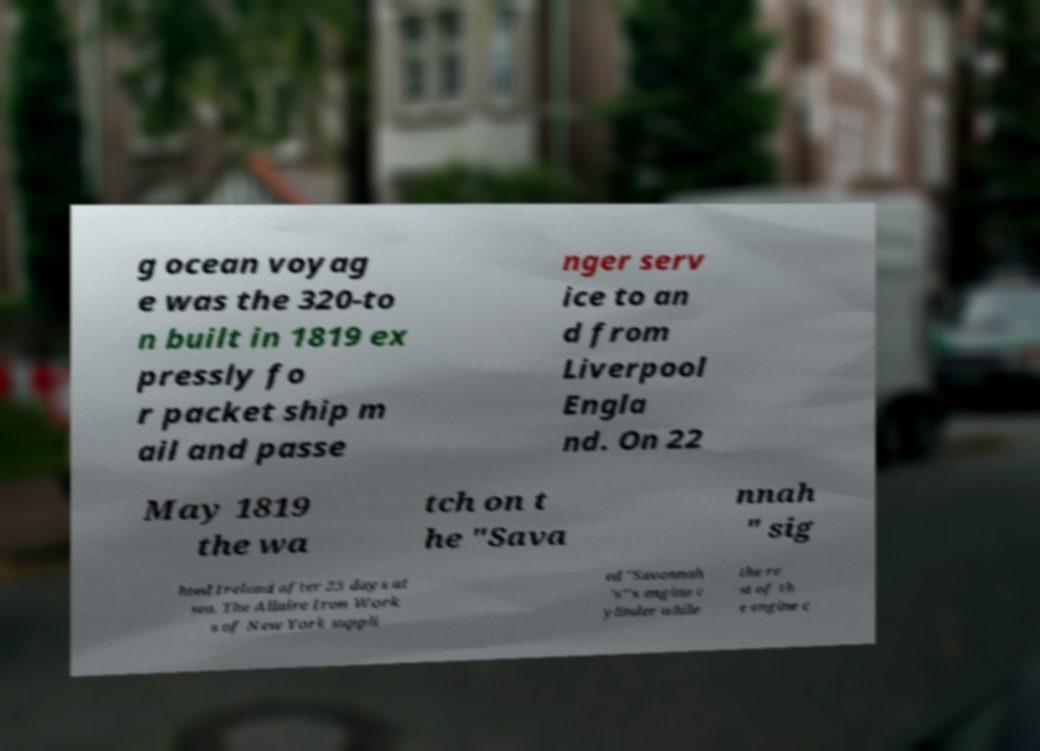Can you accurately transcribe the text from the provided image for me? g ocean voyag e was the 320-to n built in 1819 ex pressly fo r packet ship m ail and passe nger serv ice to an d from Liverpool Engla nd. On 22 May 1819 the wa tch on t he "Sava nnah " sig hted Ireland after 23 days at sea. The Allaire Iron Work s of New York suppli ed "Savannah 's"'s engine c ylinder while the re st of th e engine c 